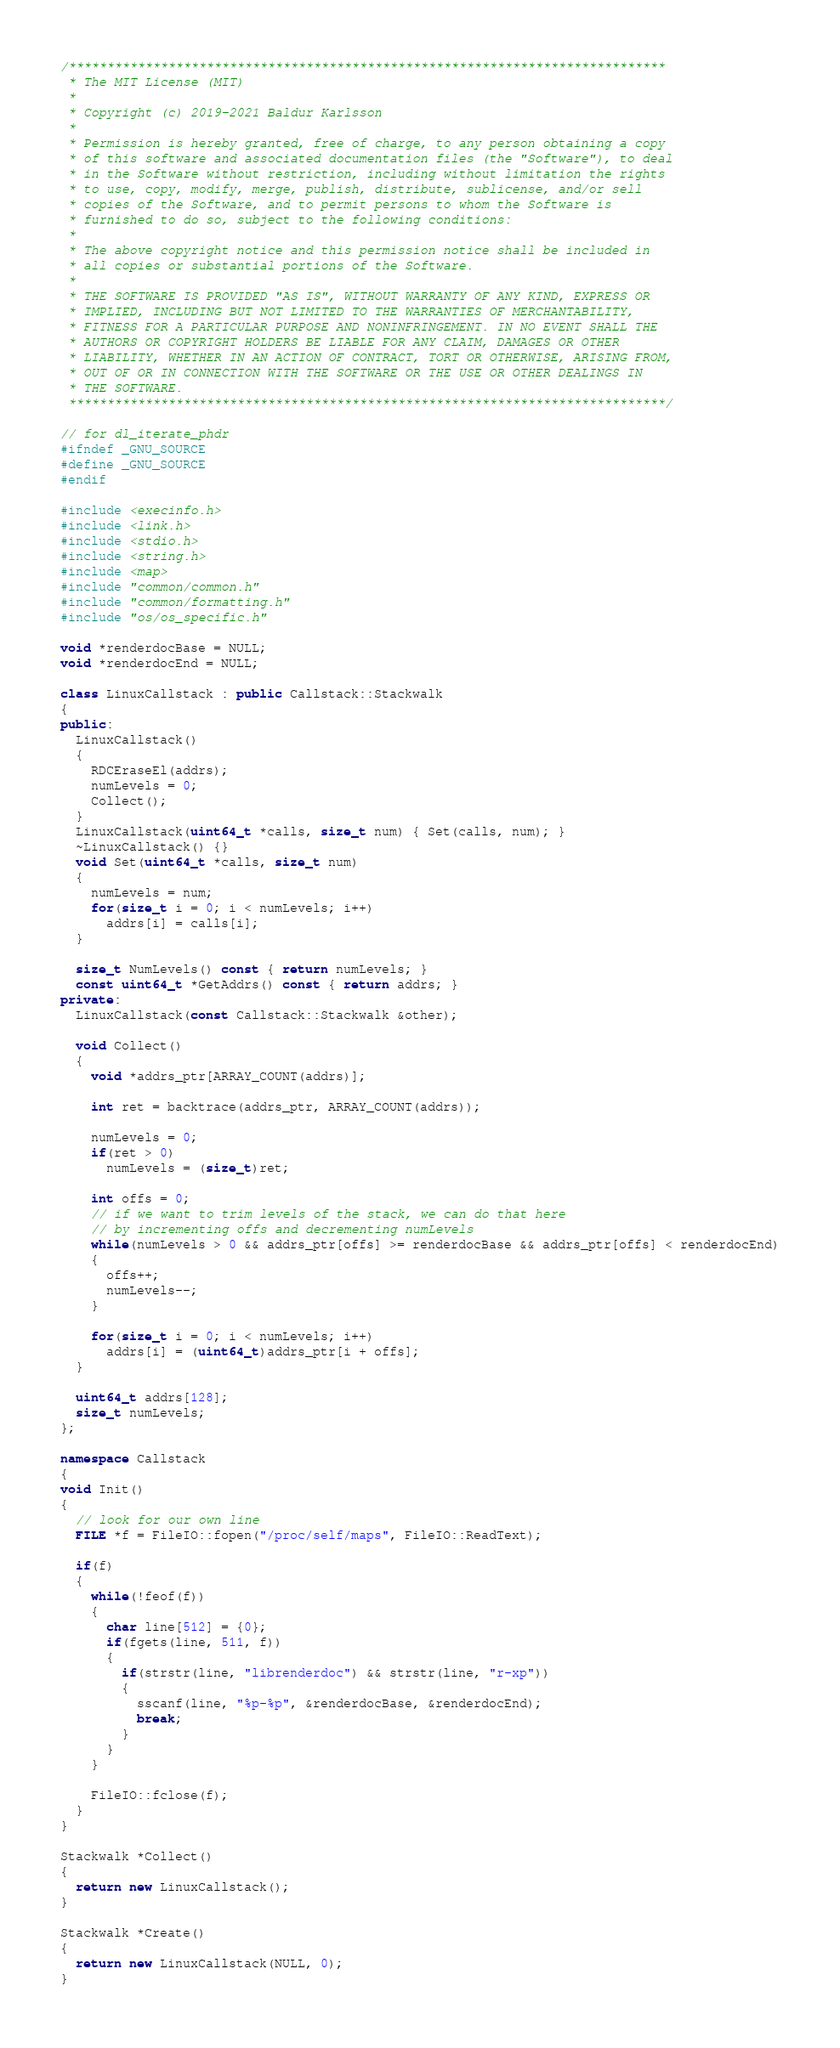<code> <loc_0><loc_0><loc_500><loc_500><_C++_>/******************************************************************************
 * The MIT License (MIT)
 *
 * Copyright (c) 2019-2021 Baldur Karlsson
 *
 * Permission is hereby granted, free of charge, to any person obtaining a copy
 * of this software and associated documentation files (the "Software"), to deal
 * in the Software without restriction, including without limitation the rights
 * to use, copy, modify, merge, publish, distribute, sublicense, and/or sell
 * copies of the Software, and to permit persons to whom the Software is
 * furnished to do so, subject to the following conditions:
 *
 * The above copyright notice and this permission notice shall be included in
 * all copies or substantial portions of the Software.
 *
 * THE SOFTWARE IS PROVIDED "AS IS", WITHOUT WARRANTY OF ANY KIND, EXPRESS OR
 * IMPLIED, INCLUDING BUT NOT LIMITED TO THE WARRANTIES OF MERCHANTABILITY,
 * FITNESS FOR A PARTICULAR PURPOSE AND NONINFRINGEMENT. IN NO EVENT SHALL THE
 * AUTHORS OR COPYRIGHT HOLDERS BE LIABLE FOR ANY CLAIM, DAMAGES OR OTHER
 * LIABILITY, WHETHER IN AN ACTION OF CONTRACT, TORT OR OTHERWISE, ARISING FROM,
 * OUT OF OR IN CONNECTION WITH THE SOFTWARE OR THE USE OR OTHER DEALINGS IN
 * THE SOFTWARE.
 ******************************************************************************/

// for dl_iterate_phdr
#ifndef _GNU_SOURCE
#define _GNU_SOURCE
#endif

#include <execinfo.h>
#include <link.h>
#include <stdio.h>
#include <string.h>
#include <map>
#include "common/common.h"
#include "common/formatting.h"
#include "os/os_specific.h"

void *renderdocBase = NULL;
void *renderdocEnd = NULL;

class LinuxCallstack : public Callstack::Stackwalk
{
public:
  LinuxCallstack()
  {
    RDCEraseEl(addrs);
    numLevels = 0;
    Collect();
  }
  LinuxCallstack(uint64_t *calls, size_t num) { Set(calls, num); }
  ~LinuxCallstack() {}
  void Set(uint64_t *calls, size_t num)
  {
    numLevels = num;
    for(size_t i = 0; i < numLevels; i++)
      addrs[i] = calls[i];
  }

  size_t NumLevels() const { return numLevels; }
  const uint64_t *GetAddrs() const { return addrs; }
private:
  LinuxCallstack(const Callstack::Stackwalk &other);

  void Collect()
  {
    void *addrs_ptr[ARRAY_COUNT(addrs)];

    int ret = backtrace(addrs_ptr, ARRAY_COUNT(addrs));

    numLevels = 0;
    if(ret > 0)
      numLevels = (size_t)ret;

    int offs = 0;
    // if we want to trim levels of the stack, we can do that here
    // by incrementing offs and decrementing numLevels
    while(numLevels > 0 && addrs_ptr[offs] >= renderdocBase && addrs_ptr[offs] < renderdocEnd)
    {
      offs++;
      numLevels--;
    }

    for(size_t i = 0; i < numLevels; i++)
      addrs[i] = (uint64_t)addrs_ptr[i + offs];
  }

  uint64_t addrs[128];
  size_t numLevels;
};

namespace Callstack
{
void Init()
{
  // look for our own line
  FILE *f = FileIO::fopen("/proc/self/maps", FileIO::ReadText);

  if(f)
  {
    while(!feof(f))
    {
      char line[512] = {0};
      if(fgets(line, 511, f))
      {
        if(strstr(line, "librenderdoc") && strstr(line, "r-xp"))
        {
          sscanf(line, "%p-%p", &renderdocBase, &renderdocEnd);
          break;
        }
      }
    }

    FileIO::fclose(f);
  }
}

Stackwalk *Collect()
{
  return new LinuxCallstack();
}

Stackwalk *Create()
{
  return new LinuxCallstack(NULL, 0);
}
</code> 